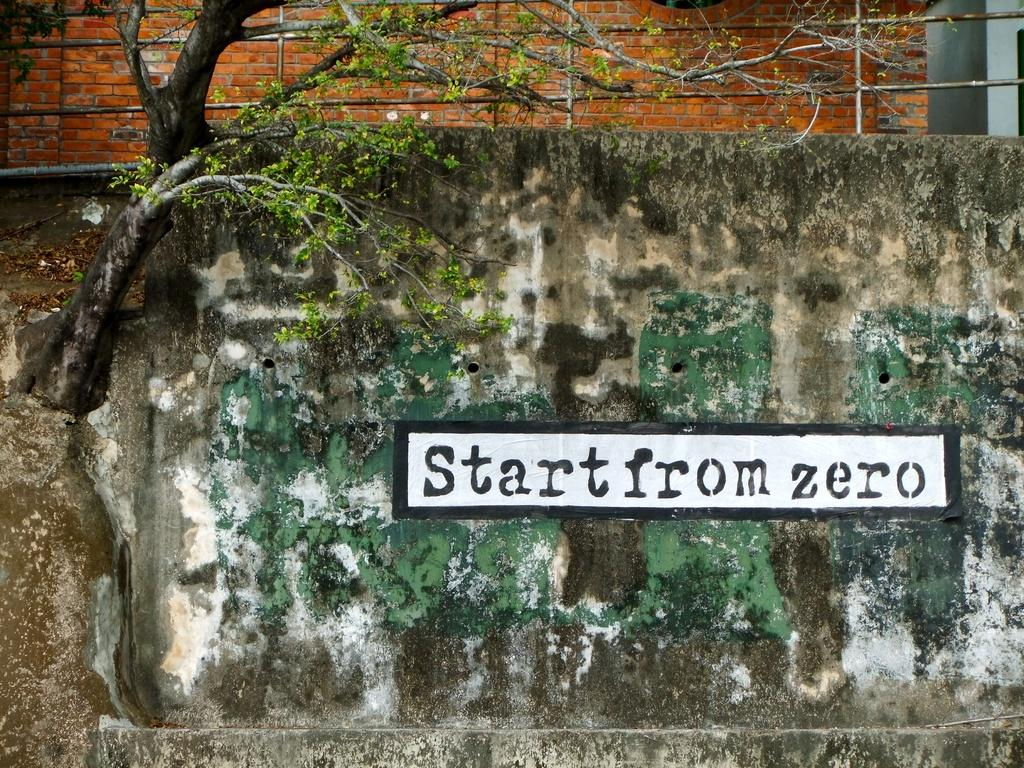What type of structure can be seen in the image? There are walls in the image, which suggests a structure. What architectural feature is present in the image? There is a grille in the image. What type of vegetation is visible in the image? There is a tree in the image. What is written or displayed on the wall in the image? There is text on the wall in the image. Can you see a net being used by the hen in the image? There is no hen or net present in the image. 